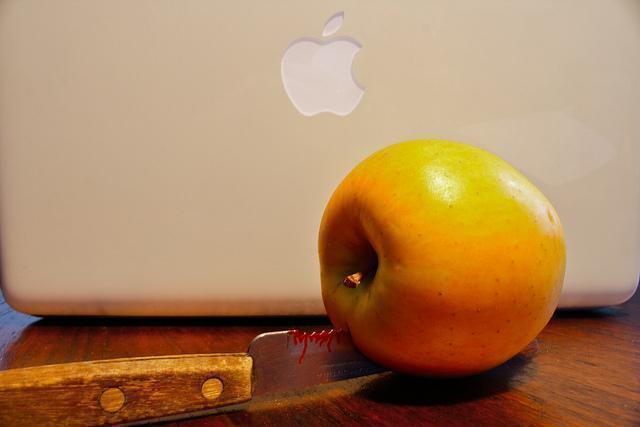What is likely the red substance on the knife?
Indicate the correct response and explain using: 'Answer: answer
Rationale: rationale.'
Options: Blood, paint, marker, crayon. Answer: paint.
Rationale: The substance is paint. 